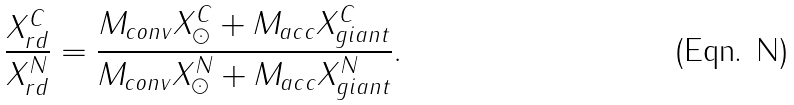Convert formula to latex. <formula><loc_0><loc_0><loc_500><loc_500>\frac { X ^ { C } _ { r d } } { X ^ { N } _ { r d } } = \frac { M _ { c o n v } X ^ { C } _ { \odot } + M _ { a c c } X ^ { C } _ { g i a n t } } { M _ { c o n v } X ^ { N } _ { \odot } + M _ { a c c } X ^ { N } _ { g i a n t } } .</formula> 